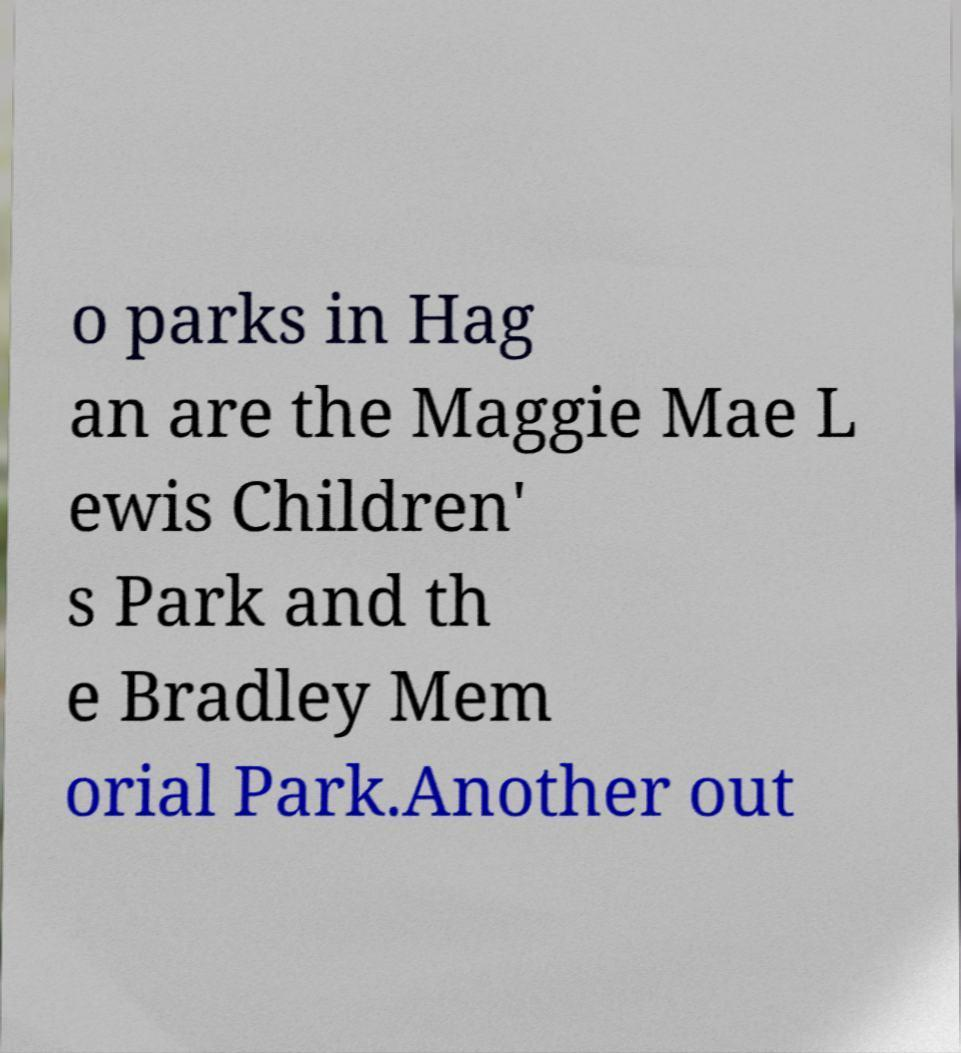Can you accurately transcribe the text from the provided image for me? o parks in Hag an are the Maggie Mae L ewis Children' s Park and th e Bradley Mem orial Park.Another out 